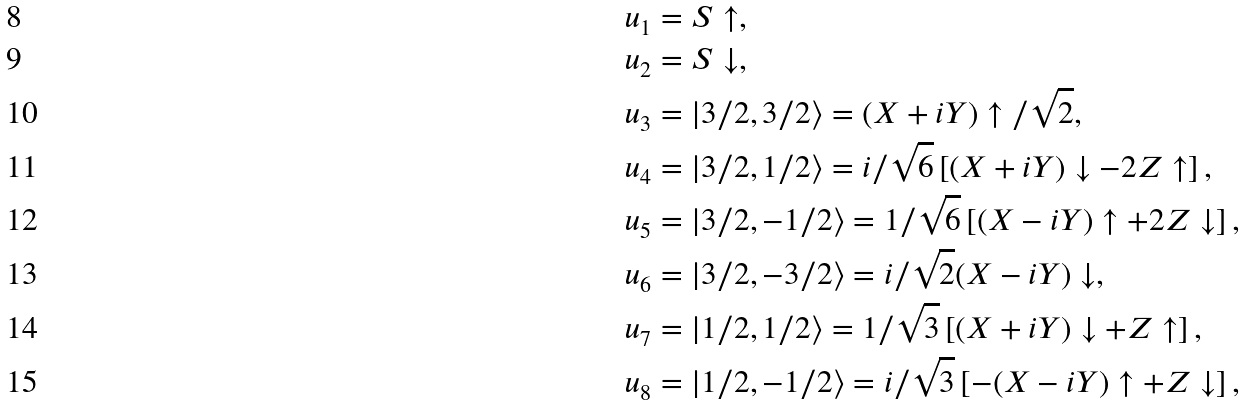Convert formula to latex. <formula><loc_0><loc_0><loc_500><loc_500>u _ { 1 } & = S \uparrow , \\ u _ { 2 } & = S \downarrow , \\ u _ { 3 } & = \left | 3 / 2 , 3 / 2 \right \rangle = ( X + i Y ) \uparrow / \sqrt { 2 } , \\ u _ { 4 } & = \left | 3 / 2 , 1 / 2 \right \rangle = i / \sqrt { 6 } \left [ ( X + i Y ) \downarrow - 2 Z \uparrow \right ] , \\ u _ { 5 } & = \left | 3 / 2 , - 1 / 2 \right \rangle = 1 / \sqrt { 6 } \left [ ( X - i Y ) \uparrow + 2 Z \downarrow \right ] , \\ u _ { 6 } & = \left | 3 / 2 , - 3 / 2 \right \rangle = i / \sqrt { 2 } ( X - i Y ) \downarrow , \\ u _ { 7 } & = \left | 1 / 2 , 1 / 2 \right \rangle = 1 / \sqrt { 3 } \left [ ( X + i Y ) \downarrow + Z \uparrow \right ] , \\ u _ { 8 } & = \left | 1 / 2 , - 1 / 2 \right \rangle = i / \sqrt { 3 } \left [ - ( X - i Y ) \uparrow + Z \downarrow \right ] ,</formula> 